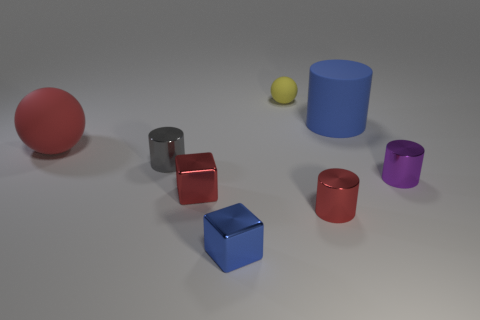Add 2 blue matte cylinders. How many objects exist? 10 Subtract all spheres. How many objects are left? 6 Add 3 cylinders. How many cylinders exist? 7 Subtract 1 red cylinders. How many objects are left? 7 Subtract all red balls. Subtract all big cylinders. How many objects are left? 6 Add 6 big red matte objects. How many big red matte objects are left? 7 